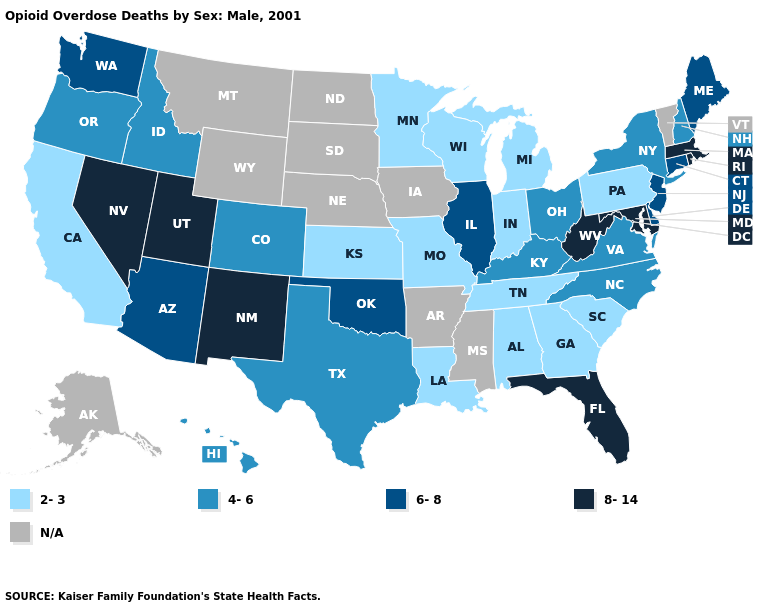Does the map have missing data?
Quick response, please. Yes. Which states have the highest value in the USA?
Answer briefly. Florida, Maryland, Massachusetts, Nevada, New Mexico, Rhode Island, Utah, West Virginia. Which states have the lowest value in the MidWest?
Keep it brief. Indiana, Kansas, Michigan, Minnesota, Missouri, Wisconsin. Which states have the lowest value in the Northeast?
Keep it brief. Pennsylvania. What is the value of Maine?
Write a very short answer. 6-8. Name the states that have a value in the range 2-3?
Concise answer only. Alabama, California, Georgia, Indiana, Kansas, Louisiana, Michigan, Minnesota, Missouri, Pennsylvania, South Carolina, Tennessee, Wisconsin. What is the lowest value in states that border Rhode Island?
Concise answer only. 6-8. Does New York have the lowest value in the Northeast?
Answer briefly. No. Is the legend a continuous bar?
Give a very brief answer. No. What is the value of Kentucky?
Write a very short answer. 4-6. What is the value of Alaska?
Answer briefly. N/A. Name the states that have a value in the range 4-6?
Be succinct. Colorado, Hawaii, Idaho, Kentucky, New Hampshire, New York, North Carolina, Ohio, Oregon, Texas, Virginia. What is the value of Wyoming?
Be succinct. N/A. What is the value of Alabama?
Write a very short answer. 2-3. What is the value of Rhode Island?
Answer briefly. 8-14. 